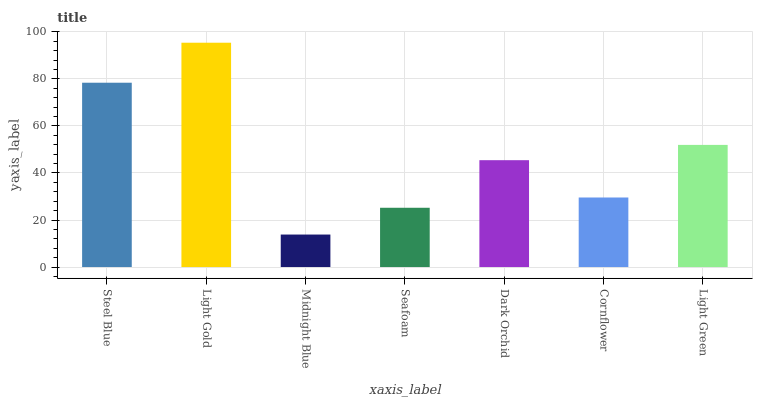Is Midnight Blue the minimum?
Answer yes or no. Yes. Is Light Gold the maximum?
Answer yes or no. Yes. Is Light Gold the minimum?
Answer yes or no. No. Is Midnight Blue the maximum?
Answer yes or no. No. Is Light Gold greater than Midnight Blue?
Answer yes or no. Yes. Is Midnight Blue less than Light Gold?
Answer yes or no. Yes. Is Midnight Blue greater than Light Gold?
Answer yes or no. No. Is Light Gold less than Midnight Blue?
Answer yes or no. No. Is Dark Orchid the high median?
Answer yes or no. Yes. Is Dark Orchid the low median?
Answer yes or no. Yes. Is Steel Blue the high median?
Answer yes or no. No. Is Light Gold the low median?
Answer yes or no. No. 